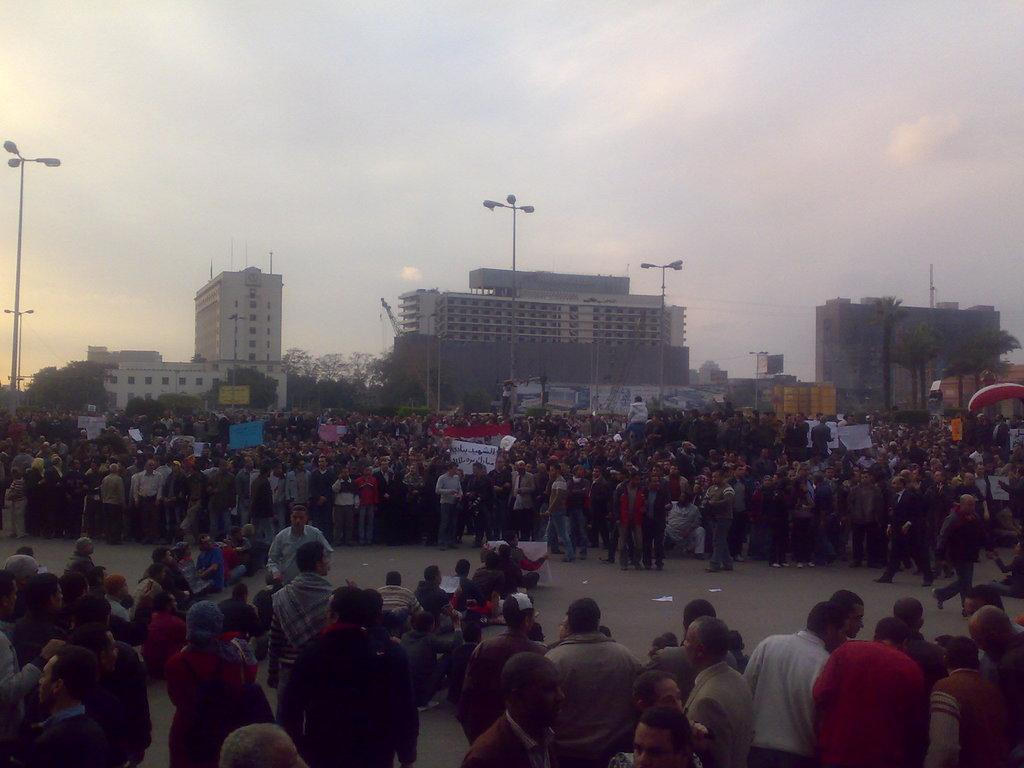Where was the image taken? The image was clicked outside. What can be seen in the middle of the image? There are many people, buildings, and trees in the middle of the image. What is visible at the top of the image? The sky is visible at the top of the image. How many fish can be seen swimming in the image? There are no fish present in the image. Are the sisters holding hands in the image? There is no mention of sisters in the image, so we cannot determine if they are holding hands. 